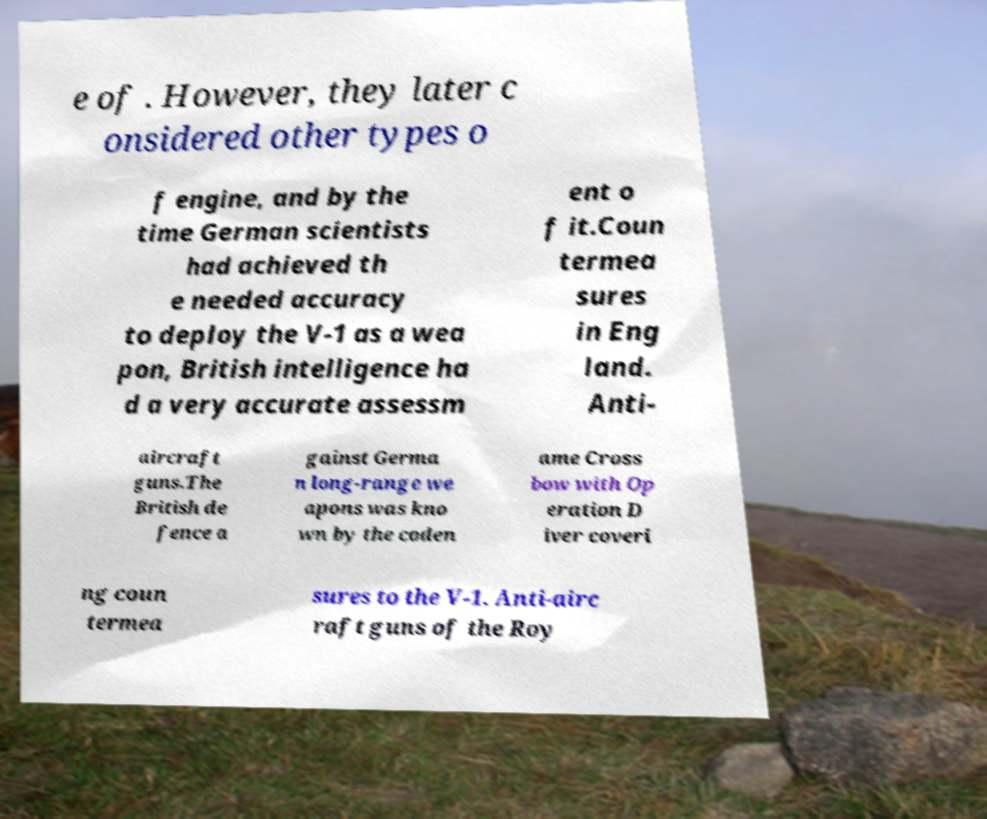I need the written content from this picture converted into text. Can you do that? e of . However, they later c onsidered other types o f engine, and by the time German scientists had achieved th e needed accuracy to deploy the V-1 as a wea pon, British intelligence ha d a very accurate assessm ent o f it.Coun termea sures in Eng land. Anti- aircraft guns.The British de fence a gainst Germa n long-range we apons was kno wn by the coden ame Cross bow with Op eration D iver coveri ng coun termea sures to the V-1. Anti-airc raft guns of the Roy 